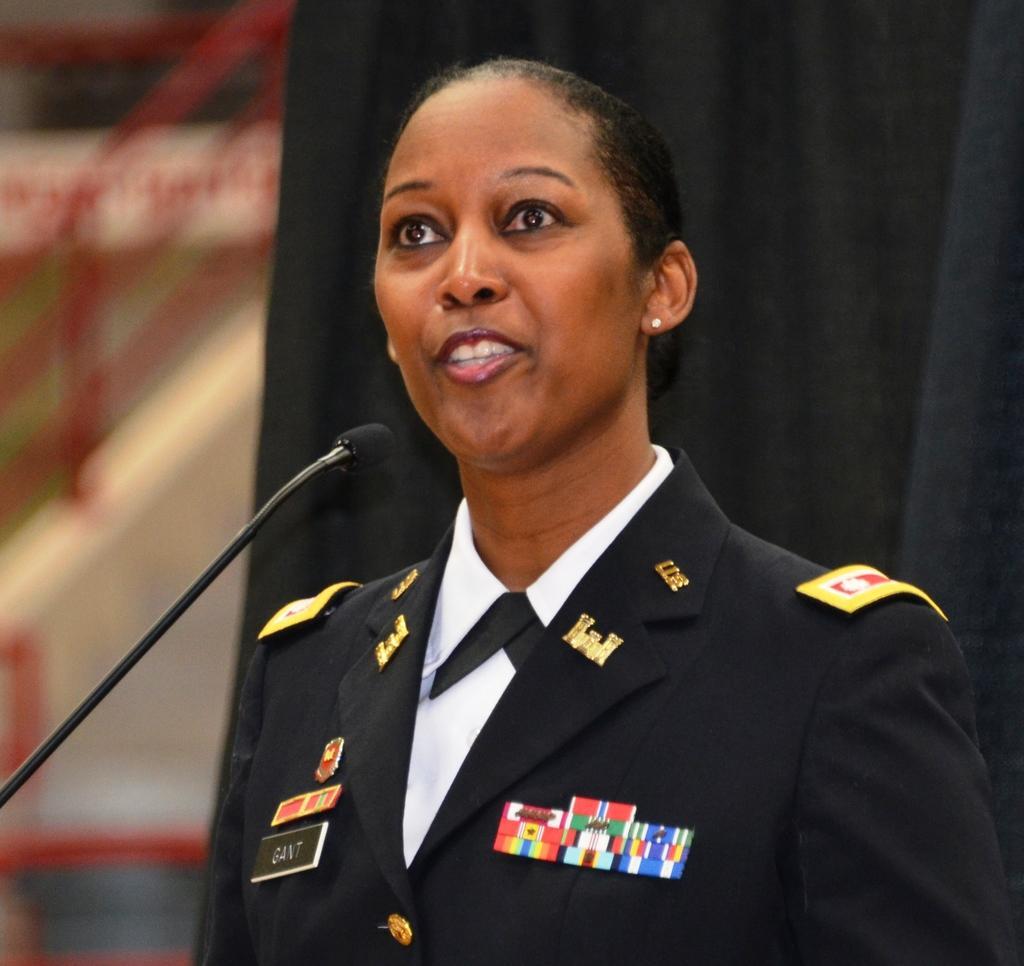Could you give a brief overview of what you see in this image? In the picture I can see a woman is wearing a uniform. Here I can see a microphone. In the background I can see a black color curtain. The background of the image is blurred. 